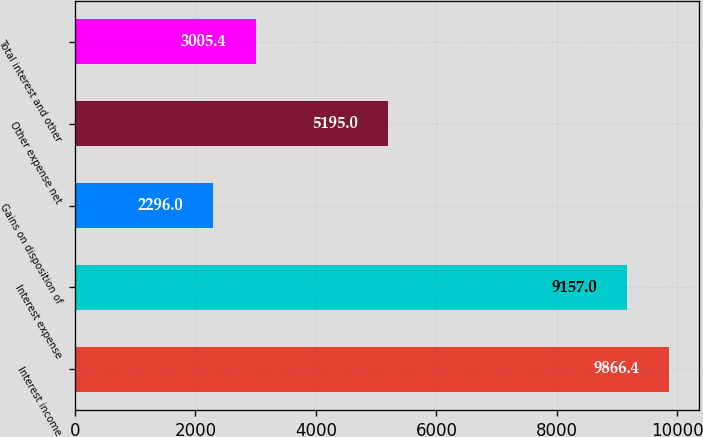Convert chart. <chart><loc_0><loc_0><loc_500><loc_500><bar_chart><fcel>Interest income<fcel>Interest expense<fcel>Gains on disposition of<fcel>Other expense net<fcel>Total interest and other<nl><fcel>9866.4<fcel>9157<fcel>2296<fcel>5195<fcel>3005.4<nl></chart> 